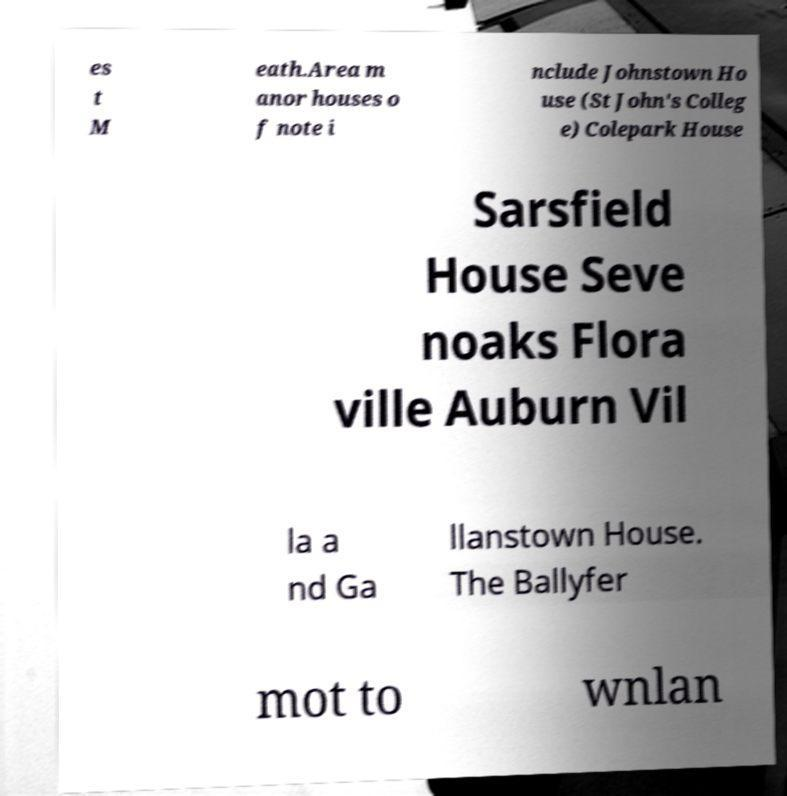I need the written content from this picture converted into text. Can you do that? es t M eath.Area m anor houses o f note i nclude Johnstown Ho use (St John's Colleg e) Colepark House Sarsfield House Seve noaks Flora ville Auburn Vil la a nd Ga llanstown House. The Ballyfer mot to wnlan 